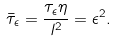<formula> <loc_0><loc_0><loc_500><loc_500>\bar { \tau } _ { \epsilon } = \frac { \tau _ { \epsilon } \eta } { l ^ { 2 } } = \epsilon ^ { 2 } .</formula> 